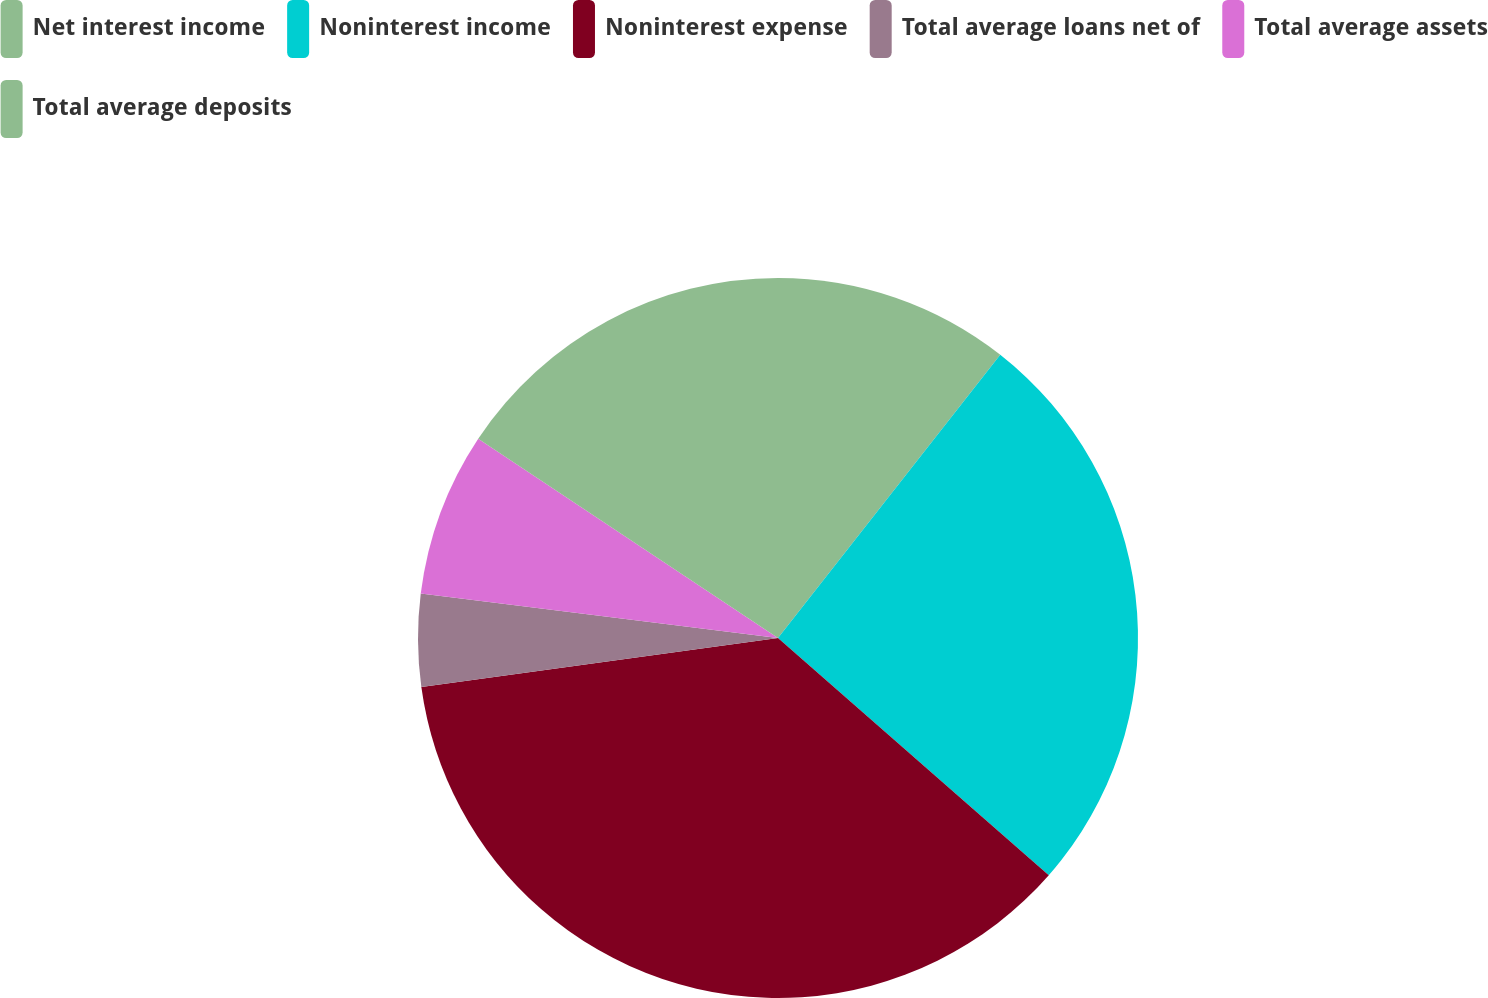Convert chart to OTSL. <chart><loc_0><loc_0><loc_500><loc_500><pie_chart><fcel>Net interest income<fcel>Noninterest income<fcel>Noninterest expense<fcel>Total average loans net of<fcel>Total average assets<fcel>Total average deposits<nl><fcel>10.59%<fcel>25.86%<fcel>36.38%<fcel>4.14%<fcel>7.37%<fcel>15.66%<nl></chart> 